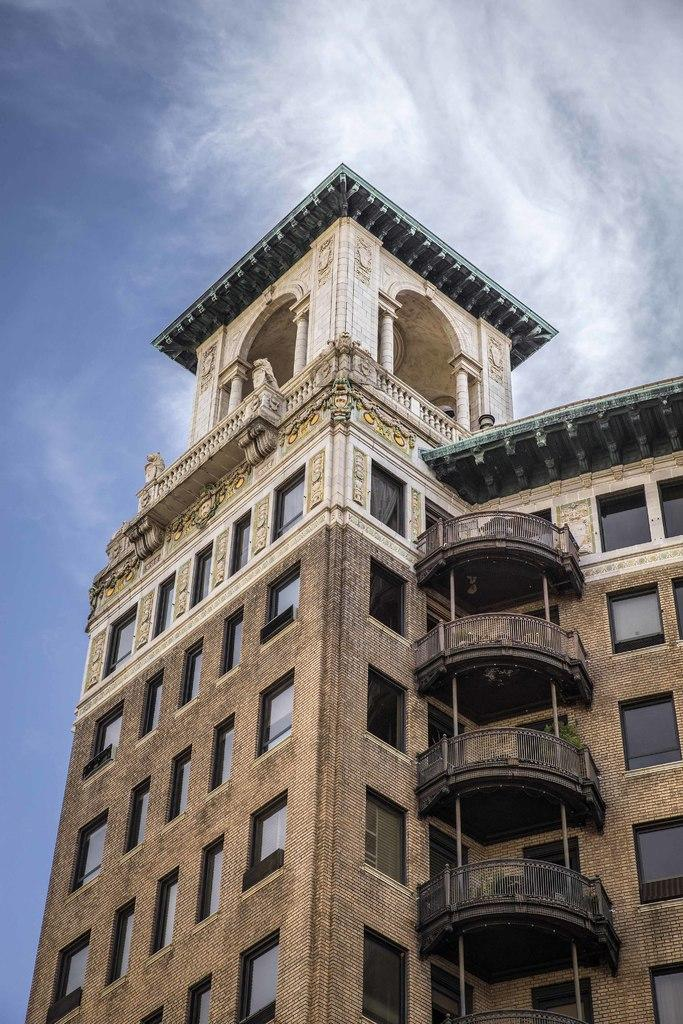What type of structure is present in the image? There is a building in the image. What feature can be seen on the building? The building has windows. Is there any artwork visible on the building? Yes, there is a sculpture visible on the wall of the building. What is visible at the top of the image? The sky is visible at the top of the image. Can you hear any protests happening near the building in the image? There is no indication of a protest in the image, and no sounds can be heard from a still image. 